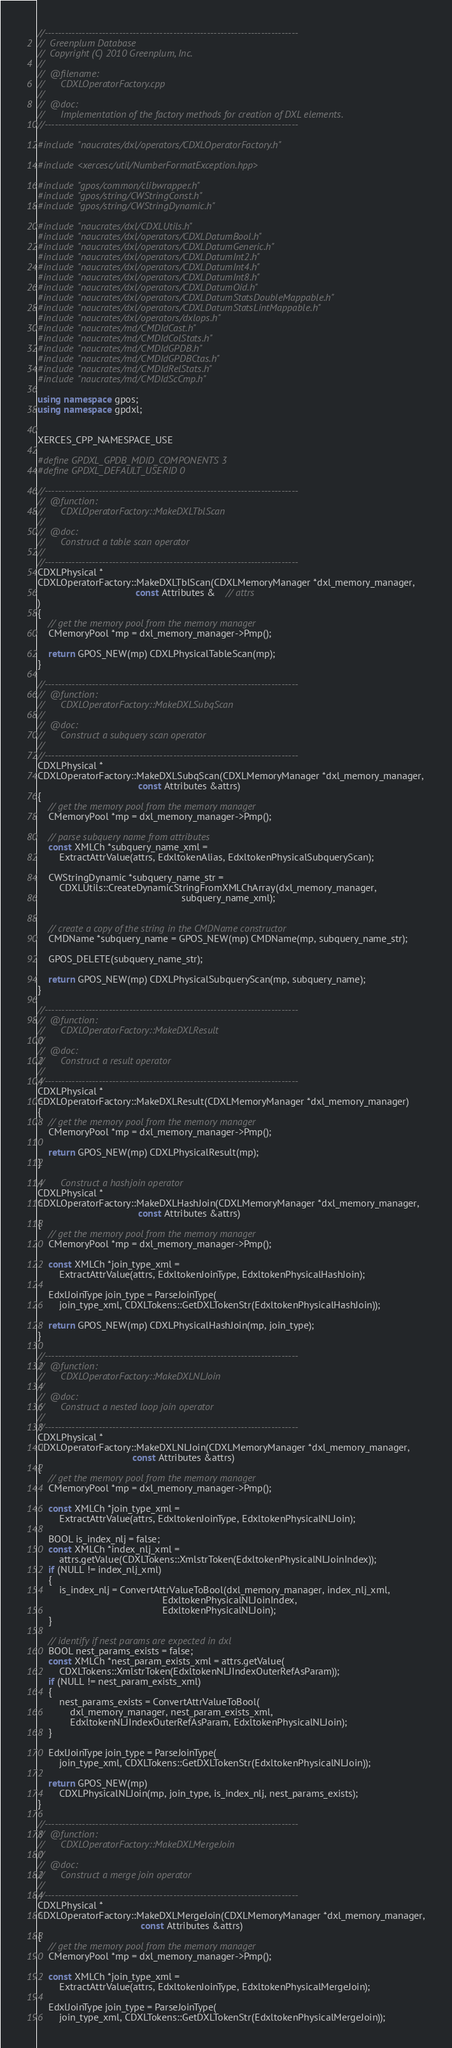Convert code to text. <code><loc_0><loc_0><loc_500><loc_500><_C++_>//---------------------------------------------------------------------------
//	Greenplum Database
//	Copyright (C) 2010 Greenplum, Inc.
//
//	@filename:
//		CDXLOperatorFactory.cpp
//
//	@doc:
//		Implementation of the factory methods for creation of DXL elements.
//---------------------------------------------------------------------------

#include "naucrates/dxl/operators/CDXLOperatorFactory.h"

#include <xercesc/util/NumberFormatException.hpp>

#include "gpos/common/clibwrapper.h"
#include "gpos/string/CWStringConst.h"
#include "gpos/string/CWStringDynamic.h"

#include "naucrates/dxl/CDXLUtils.h"
#include "naucrates/dxl/operators/CDXLDatumBool.h"
#include "naucrates/dxl/operators/CDXLDatumGeneric.h"
#include "naucrates/dxl/operators/CDXLDatumInt2.h"
#include "naucrates/dxl/operators/CDXLDatumInt4.h"
#include "naucrates/dxl/operators/CDXLDatumInt8.h"
#include "naucrates/dxl/operators/CDXLDatumOid.h"
#include "naucrates/dxl/operators/CDXLDatumStatsDoubleMappable.h"
#include "naucrates/dxl/operators/CDXLDatumStatsLintMappable.h"
#include "naucrates/dxl/operators/dxlops.h"
#include "naucrates/md/CMDIdCast.h"
#include "naucrates/md/CMDIdColStats.h"
#include "naucrates/md/CMDIdGPDB.h"
#include "naucrates/md/CMDIdGPDBCtas.h"
#include "naucrates/md/CMDIdRelStats.h"
#include "naucrates/md/CMDIdScCmp.h"

using namespace gpos;
using namespace gpdxl;


XERCES_CPP_NAMESPACE_USE

#define GPDXL_GPDB_MDID_COMPONENTS 3
#define GPDXL_DEFAULT_USERID 0

//---------------------------------------------------------------------------
//	@function:
//		CDXLOperatorFactory::MakeDXLTblScan
//
//	@doc:
//		Construct a table scan operator
//
//---------------------------------------------------------------------------
CDXLPhysical *
CDXLOperatorFactory::MakeDXLTblScan(CDXLMemoryManager *dxl_memory_manager,
									const Attributes &	// attrs
)
{
	// get the memory pool from the memory manager
	CMemoryPool *mp = dxl_memory_manager->Pmp();

	return GPOS_NEW(mp) CDXLPhysicalTableScan(mp);
}

//---------------------------------------------------------------------------
//	@function:
//		CDXLOperatorFactory::MakeDXLSubqScan
//
//	@doc:
//		Construct a subquery scan operator
//
//---------------------------------------------------------------------------
CDXLPhysical *
CDXLOperatorFactory::MakeDXLSubqScan(CDXLMemoryManager *dxl_memory_manager,
									 const Attributes &attrs)
{
	// get the memory pool from the memory manager
	CMemoryPool *mp = dxl_memory_manager->Pmp();

	// parse subquery name from attributes
	const XMLCh *subquery_name_xml =
		ExtractAttrValue(attrs, EdxltokenAlias, EdxltokenPhysicalSubqueryScan);

	CWStringDynamic *subquery_name_str =
		CDXLUtils::CreateDynamicStringFromXMLChArray(dxl_memory_manager,
													 subquery_name_xml);


	// create a copy of the string in the CMDName constructor
	CMDName *subquery_name = GPOS_NEW(mp) CMDName(mp, subquery_name_str);

	GPOS_DELETE(subquery_name_str);

	return GPOS_NEW(mp) CDXLPhysicalSubqueryScan(mp, subquery_name);
}

//---------------------------------------------------------------------------
//	@function:
//		CDXLOperatorFactory::MakeDXLResult
//
//	@doc:
//		Construct a result operator
//
//---------------------------------------------------------------------------
CDXLPhysical *
CDXLOperatorFactory::MakeDXLResult(CDXLMemoryManager *dxl_memory_manager)
{
	// get the memory pool from the memory manager
	CMemoryPool *mp = dxl_memory_manager->Pmp();

	return GPOS_NEW(mp) CDXLPhysicalResult(mp);
}

//		Construct a hashjoin operator
CDXLPhysical *
CDXLOperatorFactory::MakeDXLHashJoin(CDXLMemoryManager *dxl_memory_manager,
									 const Attributes &attrs)
{
	// get the memory pool from the memory manager
	CMemoryPool *mp = dxl_memory_manager->Pmp();

	const XMLCh *join_type_xml =
		ExtractAttrValue(attrs, EdxltokenJoinType, EdxltokenPhysicalHashJoin);

	EdxlJoinType join_type = ParseJoinType(
		join_type_xml, CDXLTokens::GetDXLTokenStr(EdxltokenPhysicalHashJoin));

	return GPOS_NEW(mp) CDXLPhysicalHashJoin(mp, join_type);
}

//---------------------------------------------------------------------------
//	@function:
//		CDXLOperatorFactory::MakeDXLNLJoin
//
//	@doc:
//		Construct a nested loop join operator
//
//---------------------------------------------------------------------------
CDXLPhysical *
CDXLOperatorFactory::MakeDXLNLJoin(CDXLMemoryManager *dxl_memory_manager,
								   const Attributes &attrs)
{
	// get the memory pool from the memory manager
	CMemoryPool *mp = dxl_memory_manager->Pmp();

	const XMLCh *join_type_xml =
		ExtractAttrValue(attrs, EdxltokenJoinType, EdxltokenPhysicalNLJoin);

	BOOL is_index_nlj = false;
	const XMLCh *index_nlj_xml =
		attrs.getValue(CDXLTokens::XmlstrToken(EdxltokenPhysicalNLJoinIndex));
	if (NULL != index_nlj_xml)
	{
		is_index_nlj = ConvertAttrValueToBool(dxl_memory_manager, index_nlj_xml,
											  EdxltokenPhysicalNLJoinIndex,
											  EdxltokenPhysicalNLJoin);
	}

	// identify if nest params are expected in dxl
	BOOL nest_params_exists = false;
	const XMLCh *nest_param_exists_xml = attrs.getValue(
		CDXLTokens::XmlstrToken(EdxltokenNLJIndexOuterRefAsParam));
	if (NULL != nest_param_exists_xml)
	{
		nest_params_exists = ConvertAttrValueToBool(
			dxl_memory_manager, nest_param_exists_xml,
			EdxltokenNLJIndexOuterRefAsParam, EdxltokenPhysicalNLJoin);
	}

	EdxlJoinType join_type = ParseJoinType(
		join_type_xml, CDXLTokens::GetDXLTokenStr(EdxltokenPhysicalNLJoin));

	return GPOS_NEW(mp)
		CDXLPhysicalNLJoin(mp, join_type, is_index_nlj, nest_params_exists);
}

//---------------------------------------------------------------------------
//	@function:
//		CDXLOperatorFactory::MakeDXLMergeJoin
//
//	@doc:
//		Construct a merge join operator
//
//---------------------------------------------------------------------------
CDXLPhysical *
CDXLOperatorFactory::MakeDXLMergeJoin(CDXLMemoryManager *dxl_memory_manager,
									  const Attributes &attrs)
{
	// get the memory pool from the memory manager
	CMemoryPool *mp = dxl_memory_manager->Pmp();

	const XMLCh *join_type_xml =
		ExtractAttrValue(attrs, EdxltokenJoinType, EdxltokenPhysicalMergeJoin);

	EdxlJoinType join_type = ParseJoinType(
		join_type_xml, CDXLTokens::GetDXLTokenStr(EdxltokenPhysicalMergeJoin));
</code> 